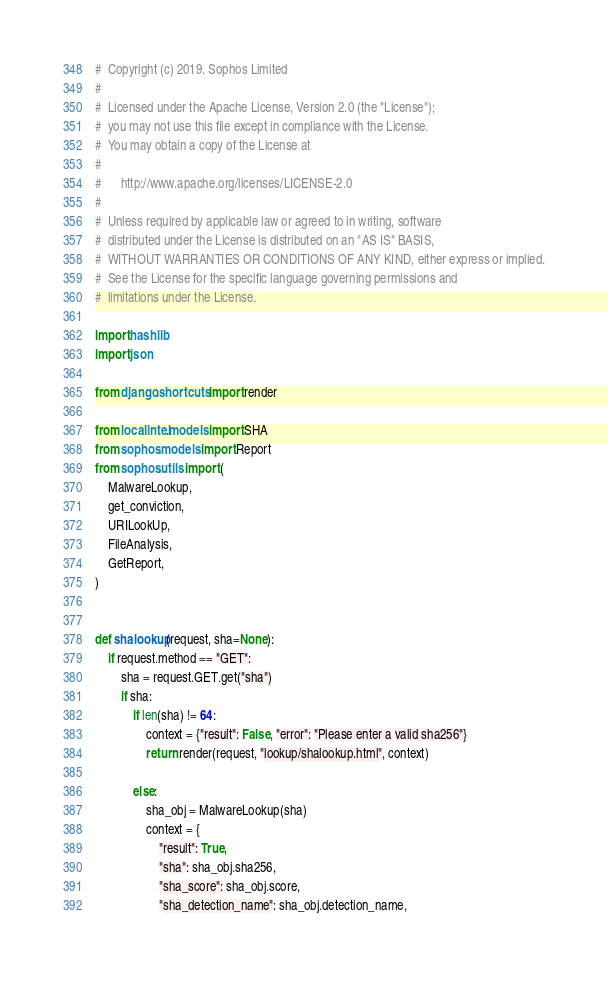<code> <loc_0><loc_0><loc_500><loc_500><_Python_>#  Copyright (c) 2019. Sophos Limited
#
#  Licensed under the Apache License, Version 2.0 (the "License");
#  you may not use this file except in compliance with the License.
#  You may obtain a copy of the License at
#
#      http://www.apache.org/licenses/LICENSE-2.0
#
#  Unless required by applicable law or agreed to in writing, software
#  distributed under the License is distributed on an "AS IS" BASIS,
#  WITHOUT WARRANTIES OR CONDITIONS OF ANY KIND, either express or implied.
#  See the License for the specific language governing permissions and
#  limitations under the License.

import hashlib
import json

from django.shortcuts import render

from localintel.models import SHA
from sophos.models import Report
from sophos.utils import (
    MalwareLookup,
    get_conviction,
    URILookUp,
    FileAnalysis,
    GetReport,
)


def shalookup(request, sha=None):
    if request.method == "GET":
        sha = request.GET.get("sha")
        if sha:
            if len(sha) != 64:
                context = {"result": False, "error": "Please enter a valid sha256"}
                return render(request, "lookup/shalookup.html", context)

            else:
                sha_obj = MalwareLookup(sha)
                context = {
                    "result": True,
                    "sha": sha_obj.sha256,
                    "sha_score": sha_obj.score,
                    "sha_detection_name": sha_obj.detection_name,</code> 